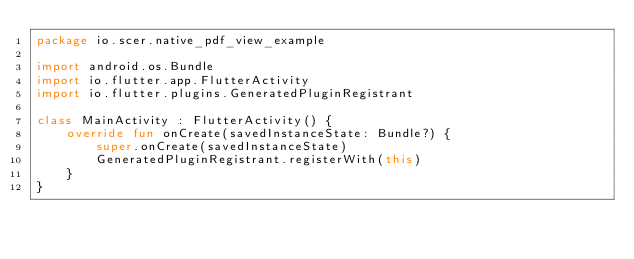Convert code to text. <code><loc_0><loc_0><loc_500><loc_500><_Kotlin_>package io.scer.native_pdf_view_example

import android.os.Bundle
import io.flutter.app.FlutterActivity
import io.flutter.plugins.GeneratedPluginRegistrant

class MainActivity : FlutterActivity() {
    override fun onCreate(savedInstanceState: Bundle?) {
        super.onCreate(savedInstanceState)
        GeneratedPluginRegistrant.registerWith(this)
    }
}
</code> 